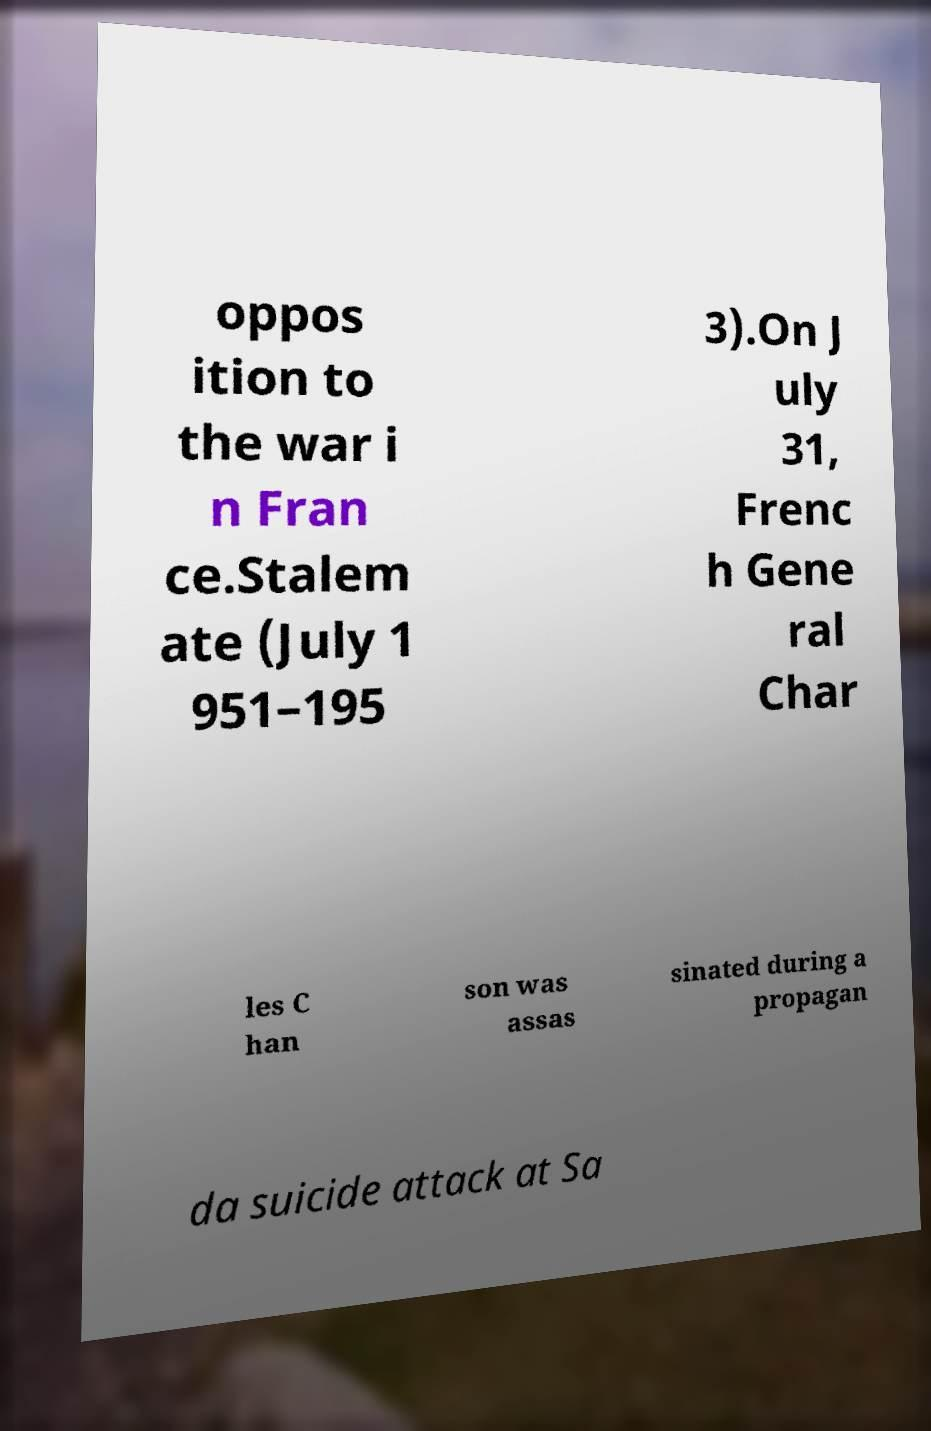There's text embedded in this image that I need extracted. Can you transcribe it verbatim? oppos ition to the war i n Fran ce.Stalem ate (July 1 951–195 3).On J uly 31, Frenc h Gene ral Char les C han son was assas sinated during a propagan da suicide attack at Sa 